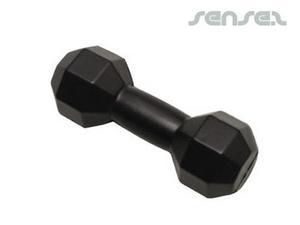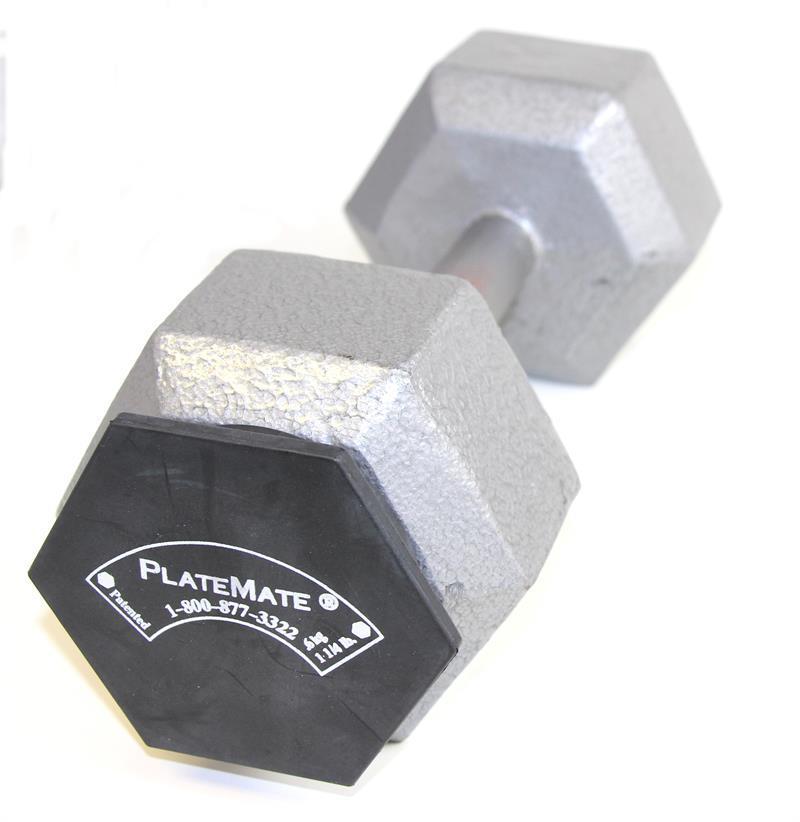The first image is the image on the left, the second image is the image on the right. Analyze the images presented: Is the assertion "There is one black free weight" valid? Answer yes or no. Yes. The first image is the image on the left, the second image is the image on the right. Assess this claim about the two images: "AN image shows exactly one black dumbbell.". Correct or not? Answer yes or no. Yes. 